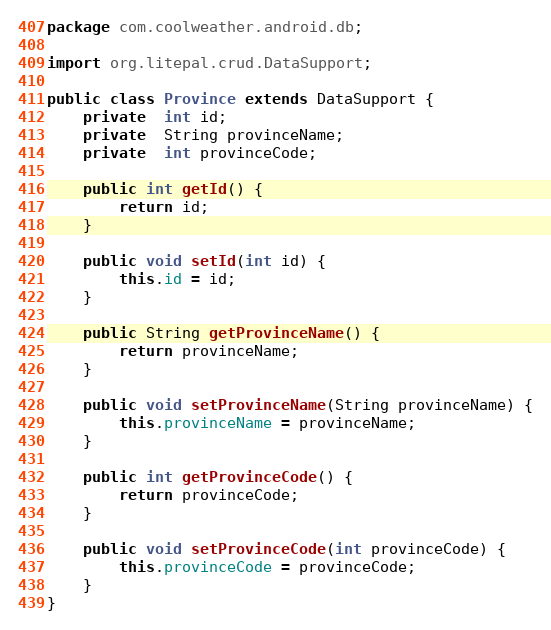Convert code to text. <code><loc_0><loc_0><loc_500><loc_500><_Java_>package com.coolweather.android.db;

import org.litepal.crud.DataSupport;

public class Province extends DataSupport {
    private  int id;
    private  String provinceName;
    private  int provinceCode;

    public int getId() {
        return id;
    }

    public void setId(int id) {
        this.id = id;
    }

    public String getProvinceName() {
        return provinceName;
    }

    public void setProvinceName(String provinceName) {
        this.provinceName = provinceName;
    }

    public int getProvinceCode() {
        return provinceCode;
    }

    public void setProvinceCode(int provinceCode) {
        this.provinceCode = provinceCode;
    }
}
</code> 